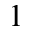<formula> <loc_0><loc_0><loc_500><loc_500>1</formula> 